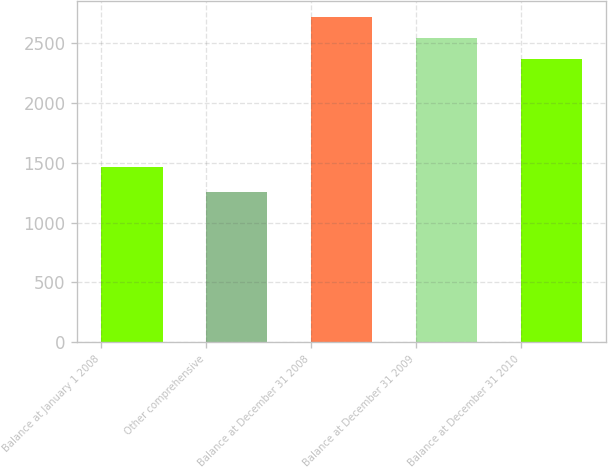Convert chart to OTSL. <chart><loc_0><loc_0><loc_500><loc_500><bar_chart><fcel>Balance at January 1 2008<fcel>Other comprehensive<fcel>Balance at December 31 2008<fcel>Balance at December 31 2009<fcel>Balance at December 31 2010<nl><fcel>1461<fcel>1258<fcel>2719<fcel>2541<fcel>2371<nl></chart> 